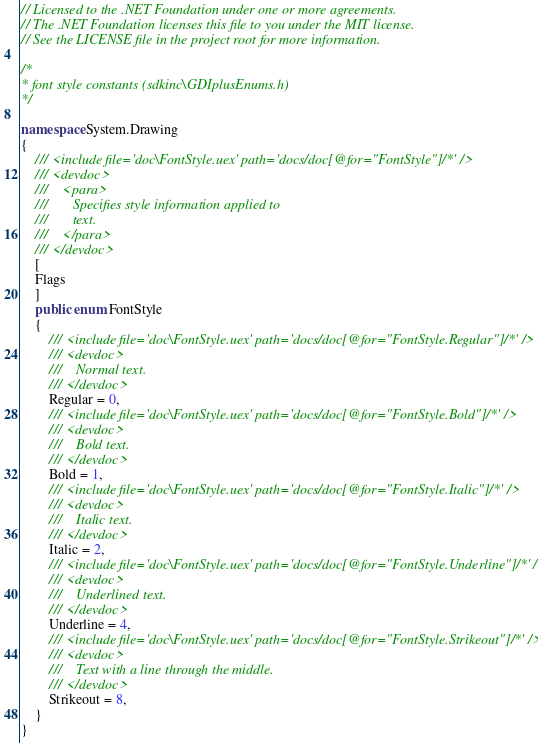Convert code to text. <code><loc_0><loc_0><loc_500><loc_500><_C#_>// Licensed to the .NET Foundation under one or more agreements.
// The .NET Foundation licenses this file to you under the MIT license.
// See the LICENSE file in the project root for more information.

/*
* font style constants (sdkinc\GDIplusEnums.h)
*/

namespace System.Drawing
{
    /// <include file='doc\FontStyle.uex' path='docs/doc[@for="FontStyle"]/*' />
    /// <devdoc>
    ///    <para>
    ///       Specifies style information applied to
    ///       text.
    ///    </para>
    /// </devdoc>
    [
    Flags
    ]
    public enum FontStyle
    {
        /// <include file='doc\FontStyle.uex' path='docs/doc[@for="FontStyle.Regular"]/*' />
        /// <devdoc>
        ///    Normal text.
        /// </devdoc>
        Regular = 0,
        /// <include file='doc\FontStyle.uex' path='docs/doc[@for="FontStyle.Bold"]/*' />
        /// <devdoc>
        ///    Bold text.
        /// </devdoc>
        Bold = 1,
        /// <include file='doc\FontStyle.uex' path='docs/doc[@for="FontStyle.Italic"]/*' />
        /// <devdoc>
        ///    Italic text.
        /// </devdoc>
        Italic = 2,
        /// <include file='doc\FontStyle.uex' path='docs/doc[@for="FontStyle.Underline"]/*' />
        /// <devdoc>
        ///    Underlined text.
        /// </devdoc>
        Underline = 4,
        /// <include file='doc\FontStyle.uex' path='docs/doc[@for="FontStyle.Strikeout"]/*' />
        /// <devdoc>
        ///    Text with a line through the middle.
        /// </devdoc>
        Strikeout = 8,
    }
}

</code> 